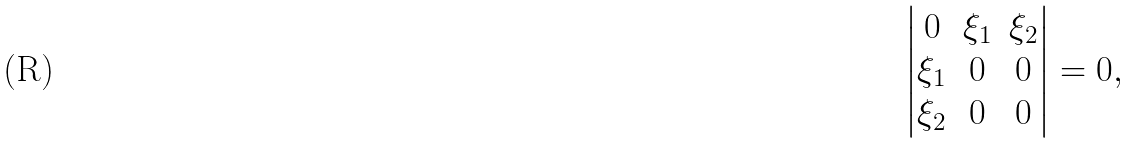Convert formula to latex. <formula><loc_0><loc_0><loc_500><loc_500>\begin{vmatrix} 0 & \xi _ { 1 } & \xi _ { 2 } \\ \xi _ { 1 } & 0 & 0 \\ \xi _ { 2 } & 0 & 0 \end{vmatrix} = 0 ,</formula> 